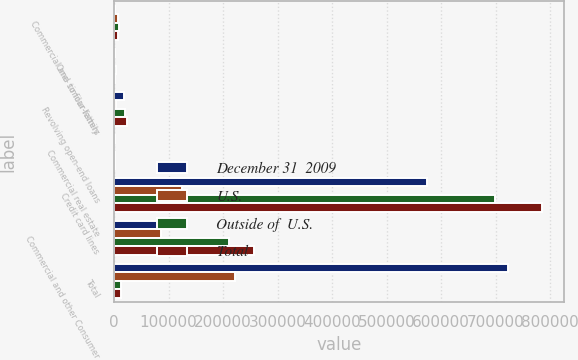<chart> <loc_0><loc_0><loc_500><loc_500><stacked_bar_chart><ecel><fcel>Commercial and similar letters<fcel>One- to four-family<fcel>Revolving open-end loans<fcel>Commercial real estate<fcel>Credit card lines<fcel>Commercial and other Consumer<fcel>Total<nl><fcel>December 31  2009<fcel>1544<fcel>2582<fcel>17986<fcel>1813<fcel>573945<fcel>124142<fcel>722012<nl><fcel>U.S.<fcel>7430<fcel>398<fcel>2948<fcel>594<fcel>124728<fcel>86262<fcel>222360<nl><fcel>Outside of  U.S.<fcel>8974<fcel>2980<fcel>20934<fcel>2407<fcel>698673<fcel>210404<fcel>13480<nl><fcel>Total<fcel>7211<fcel>1070<fcel>23916<fcel>1704<fcel>785495<fcel>257342<fcel>13480<nl></chart> 